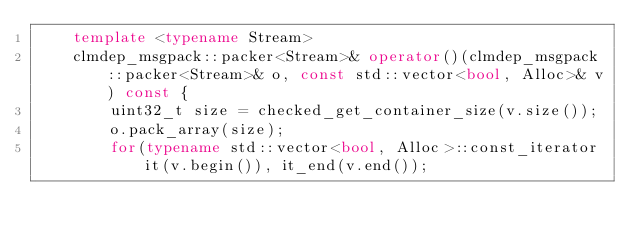Convert code to text. <code><loc_0><loc_0><loc_500><loc_500><_C++_>    template <typename Stream>
    clmdep_msgpack::packer<Stream>& operator()(clmdep_msgpack::packer<Stream>& o, const std::vector<bool, Alloc>& v) const {
        uint32_t size = checked_get_container_size(v.size());
        o.pack_array(size);
        for(typename std::vector<bool, Alloc>::const_iterator it(v.begin()), it_end(v.end());</code> 